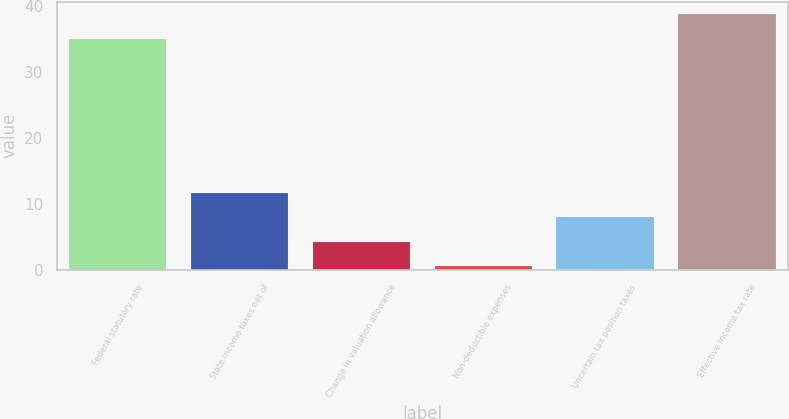<chart> <loc_0><loc_0><loc_500><loc_500><bar_chart><fcel>Federal statutory rate<fcel>State income taxes net of<fcel>Change in valuation allowance<fcel>Non-deductible expenses<fcel>Uncertain tax position taxes<fcel>Effective income tax rate<nl><fcel>35<fcel>11.61<fcel>4.27<fcel>0.6<fcel>7.94<fcel>38.67<nl></chart> 